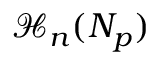Convert formula to latex. <formula><loc_0><loc_0><loc_500><loc_500>\mathcal { H } _ { n } ( N _ { p } )</formula> 